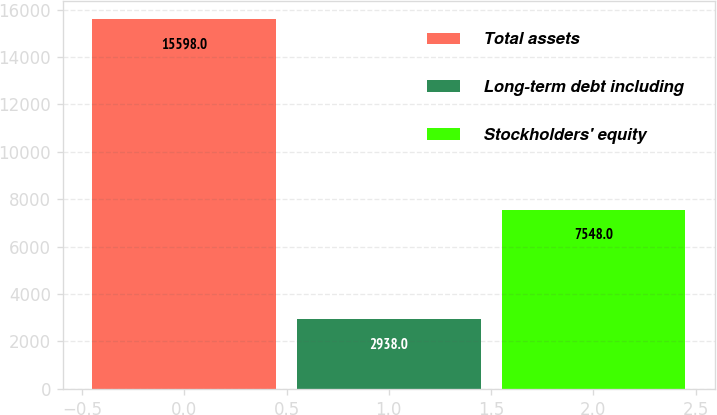Convert chart to OTSL. <chart><loc_0><loc_0><loc_500><loc_500><bar_chart><fcel>Total assets<fcel>Long-term debt including<fcel>Stockholders' equity<nl><fcel>15598<fcel>2938<fcel>7548<nl></chart> 